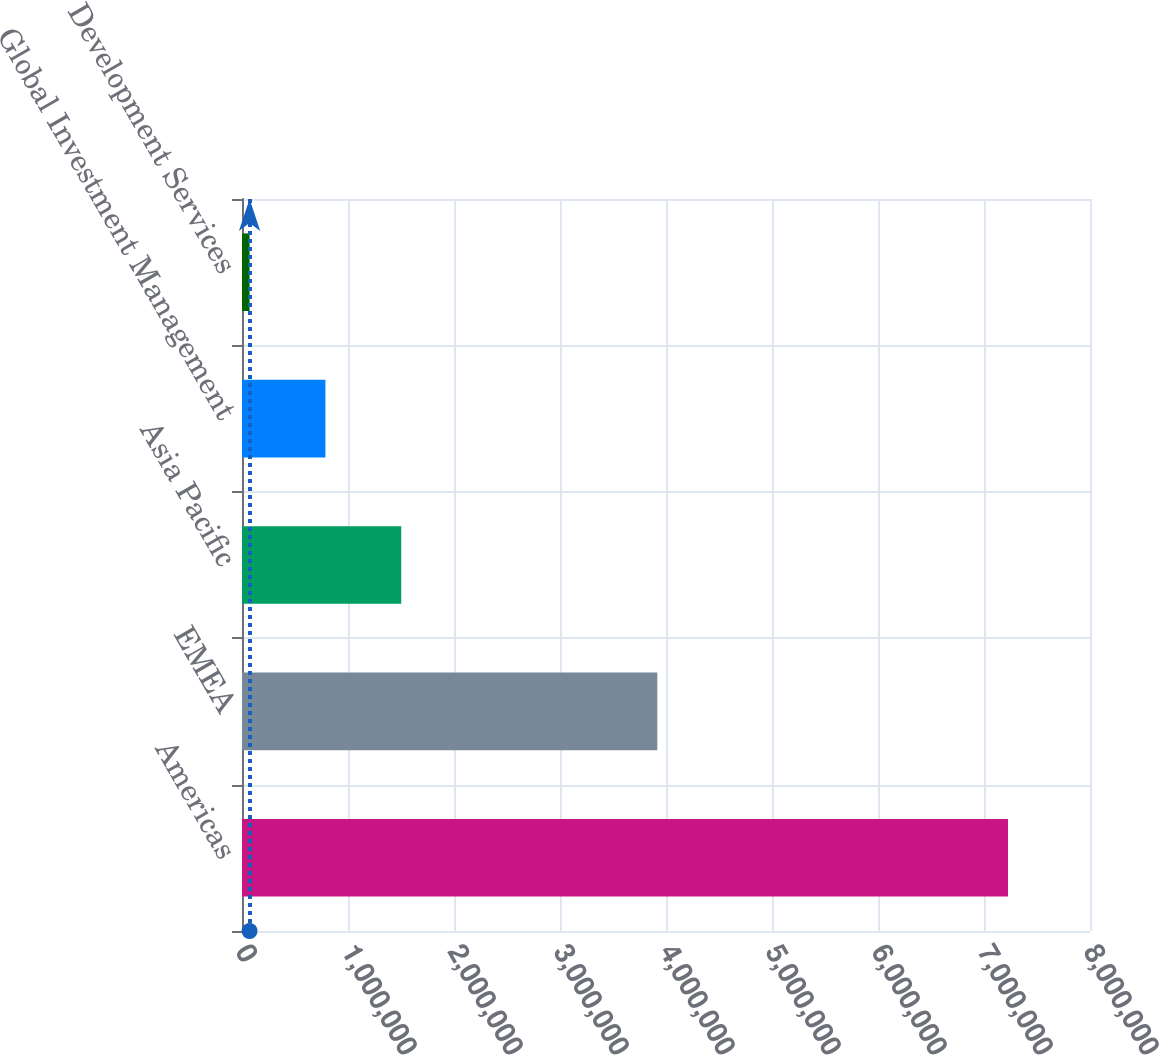Convert chart to OTSL. <chart><loc_0><loc_0><loc_500><loc_500><bar_chart><fcel>Americas<fcel>EMEA<fcel>Asia Pacific<fcel>Global Investment Management<fcel>Development Services<nl><fcel>7.22647e+06<fcel>3.91794e+06<fcel>1.50242e+06<fcel>786919<fcel>71414<nl></chart> 